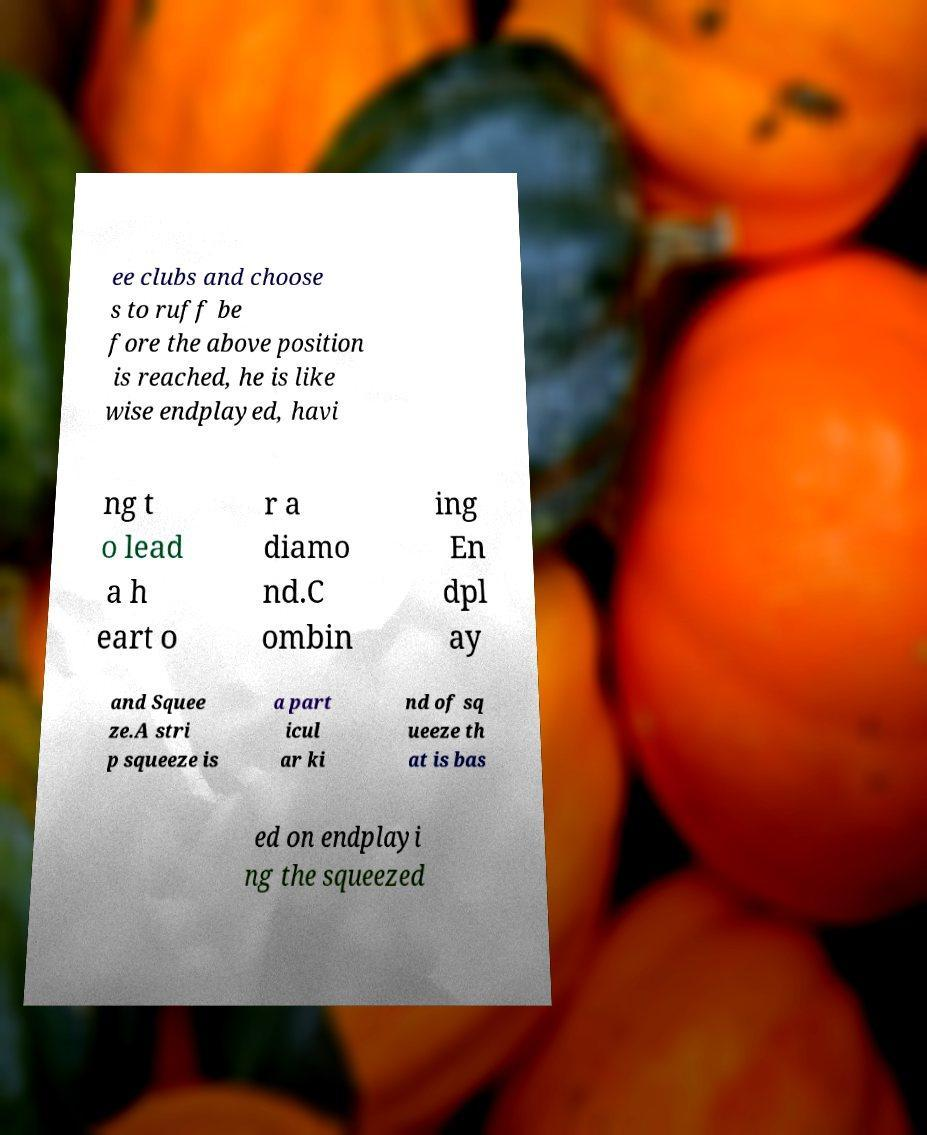For documentation purposes, I need the text within this image transcribed. Could you provide that? ee clubs and choose s to ruff be fore the above position is reached, he is like wise endplayed, havi ng t o lead a h eart o r a diamo nd.C ombin ing En dpl ay and Squee ze.A stri p squeeze is a part icul ar ki nd of sq ueeze th at is bas ed on endplayi ng the squeezed 